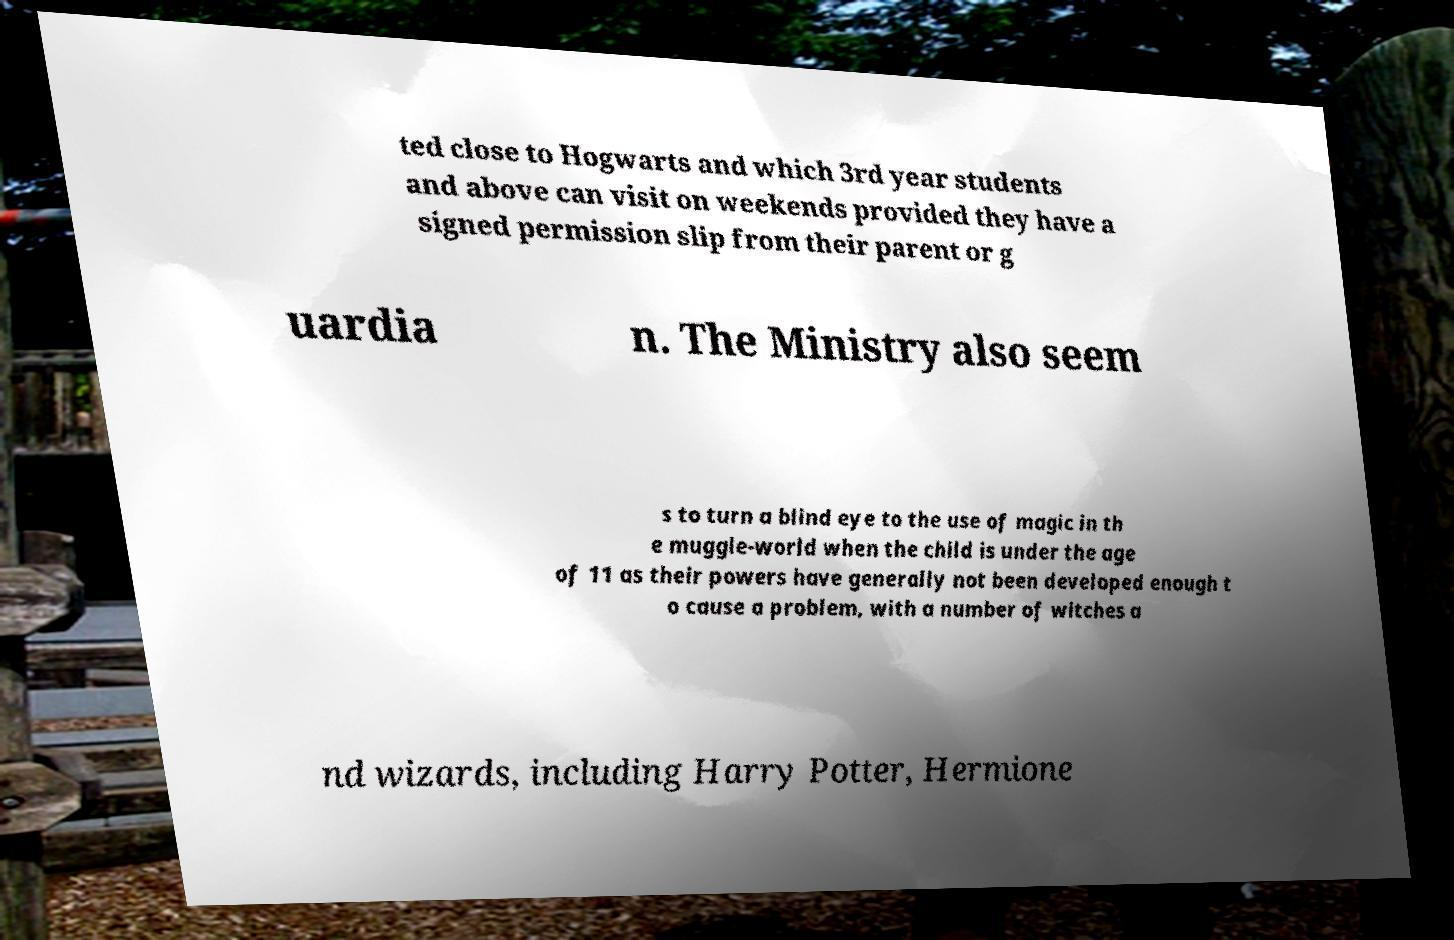Could you assist in decoding the text presented in this image and type it out clearly? ted close to Hogwarts and which 3rd year students and above can visit on weekends provided they have a signed permission slip from their parent or g uardia n. The Ministry also seem s to turn a blind eye to the use of magic in th e muggle-world when the child is under the age of 11 as their powers have generally not been developed enough t o cause a problem, with a number of witches a nd wizards, including Harry Potter, Hermione 